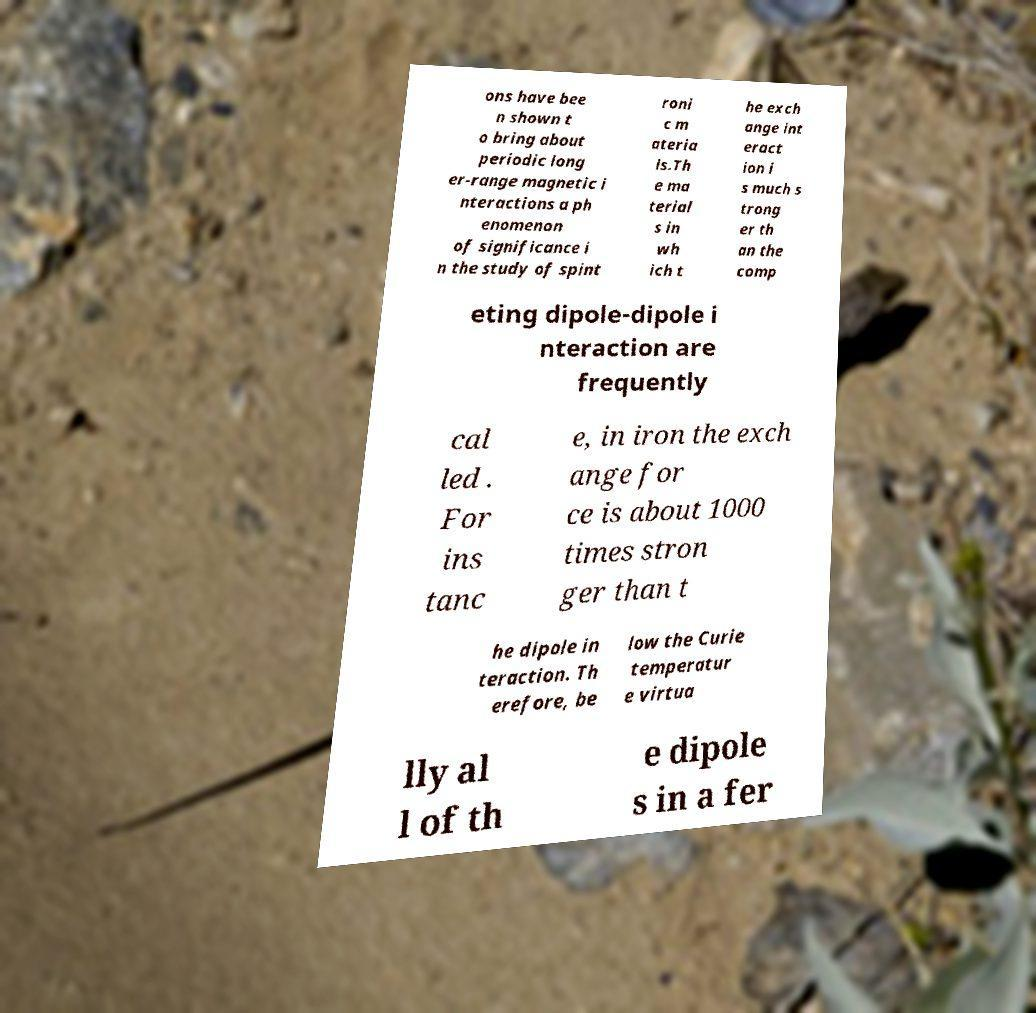For documentation purposes, I need the text within this image transcribed. Could you provide that? ons have bee n shown t o bring about periodic long er-range magnetic i nteractions a ph enomenon of significance i n the study of spint roni c m ateria ls.Th e ma terial s in wh ich t he exch ange int eract ion i s much s trong er th an the comp eting dipole-dipole i nteraction are frequently cal led . For ins tanc e, in iron the exch ange for ce is about 1000 times stron ger than t he dipole in teraction. Th erefore, be low the Curie temperatur e virtua lly al l of th e dipole s in a fer 